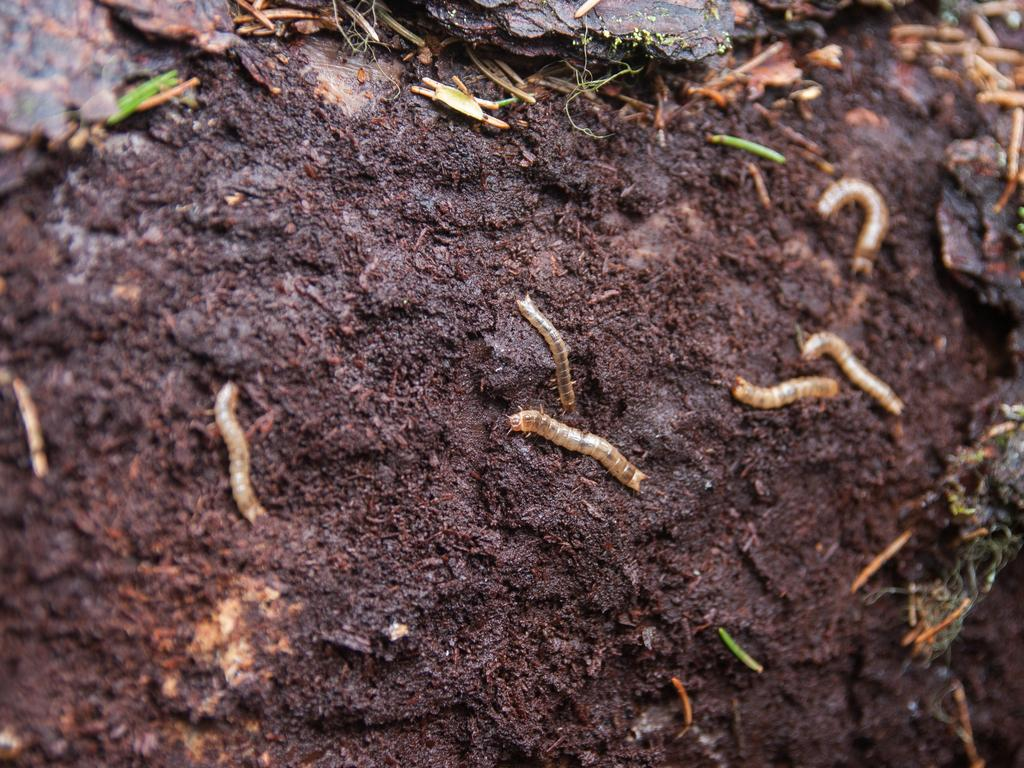What type of surface is shown in the image? The image appears to depict soil. What type of living organisms can be seen in the image? There are many worms visible in the image. What is the limit of the worms' attention span in the image? There is no information provided about the worms' attention span in the image. What is the name of the worm on the left side of the image? There is no specific worm identified on the left side of the image, and worms do not have names. 